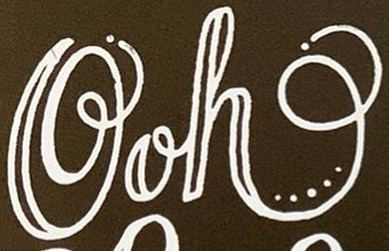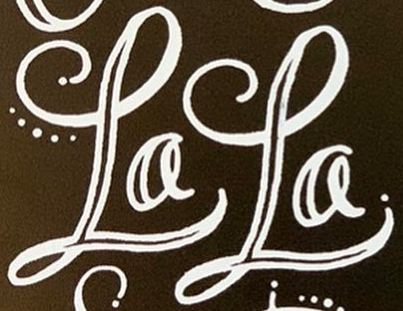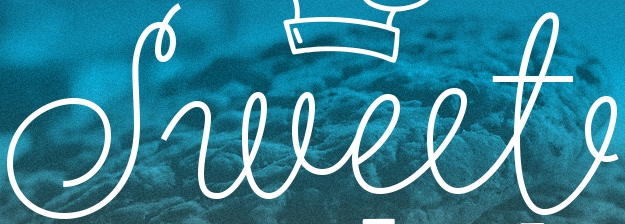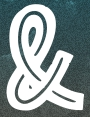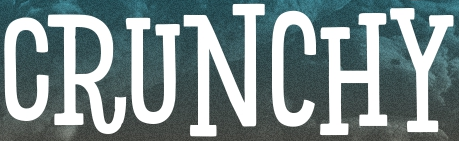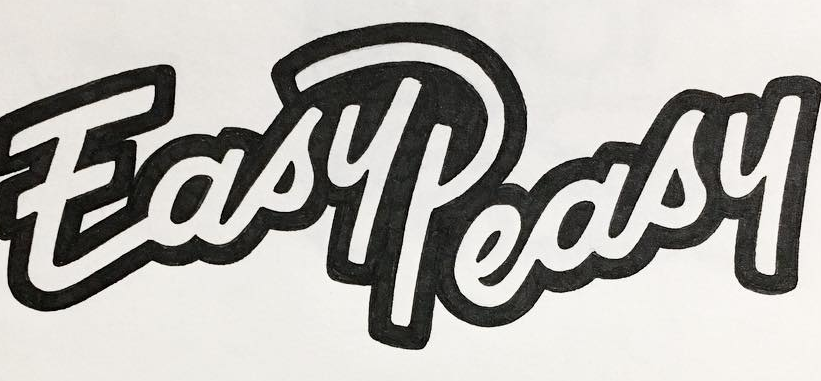Identify the words shown in these images in order, separated by a semicolon. Ooh; LaLa; Sweet; &; CRUNCHY; EasyPeasy 